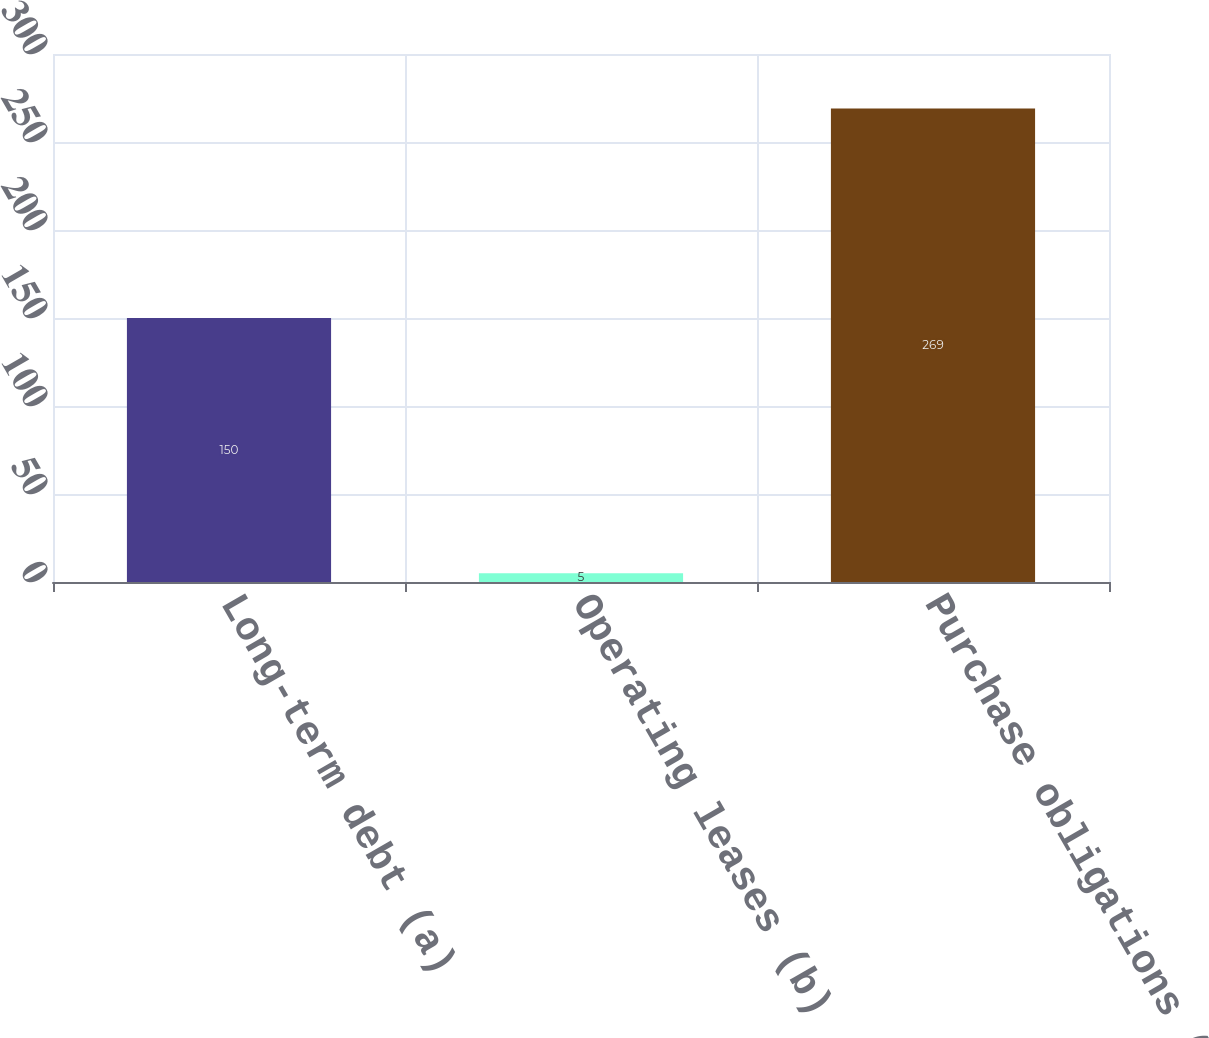<chart> <loc_0><loc_0><loc_500><loc_500><bar_chart><fcel>Long-term debt (a)<fcel>Operating leases (b)<fcel>Purchase obligations (c)<nl><fcel>150<fcel>5<fcel>269<nl></chart> 